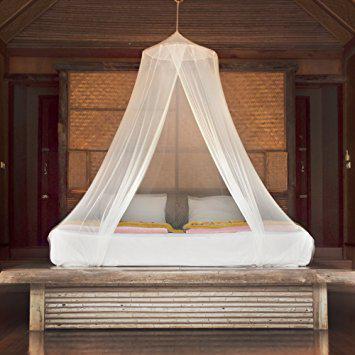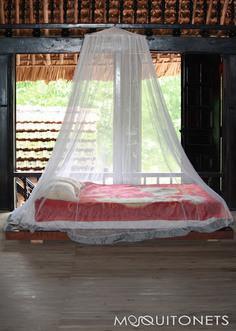The first image is the image on the left, the second image is the image on the right. For the images shown, is this caption "The netting in the image on the left is suspended from its corners." true? Answer yes or no. No. 